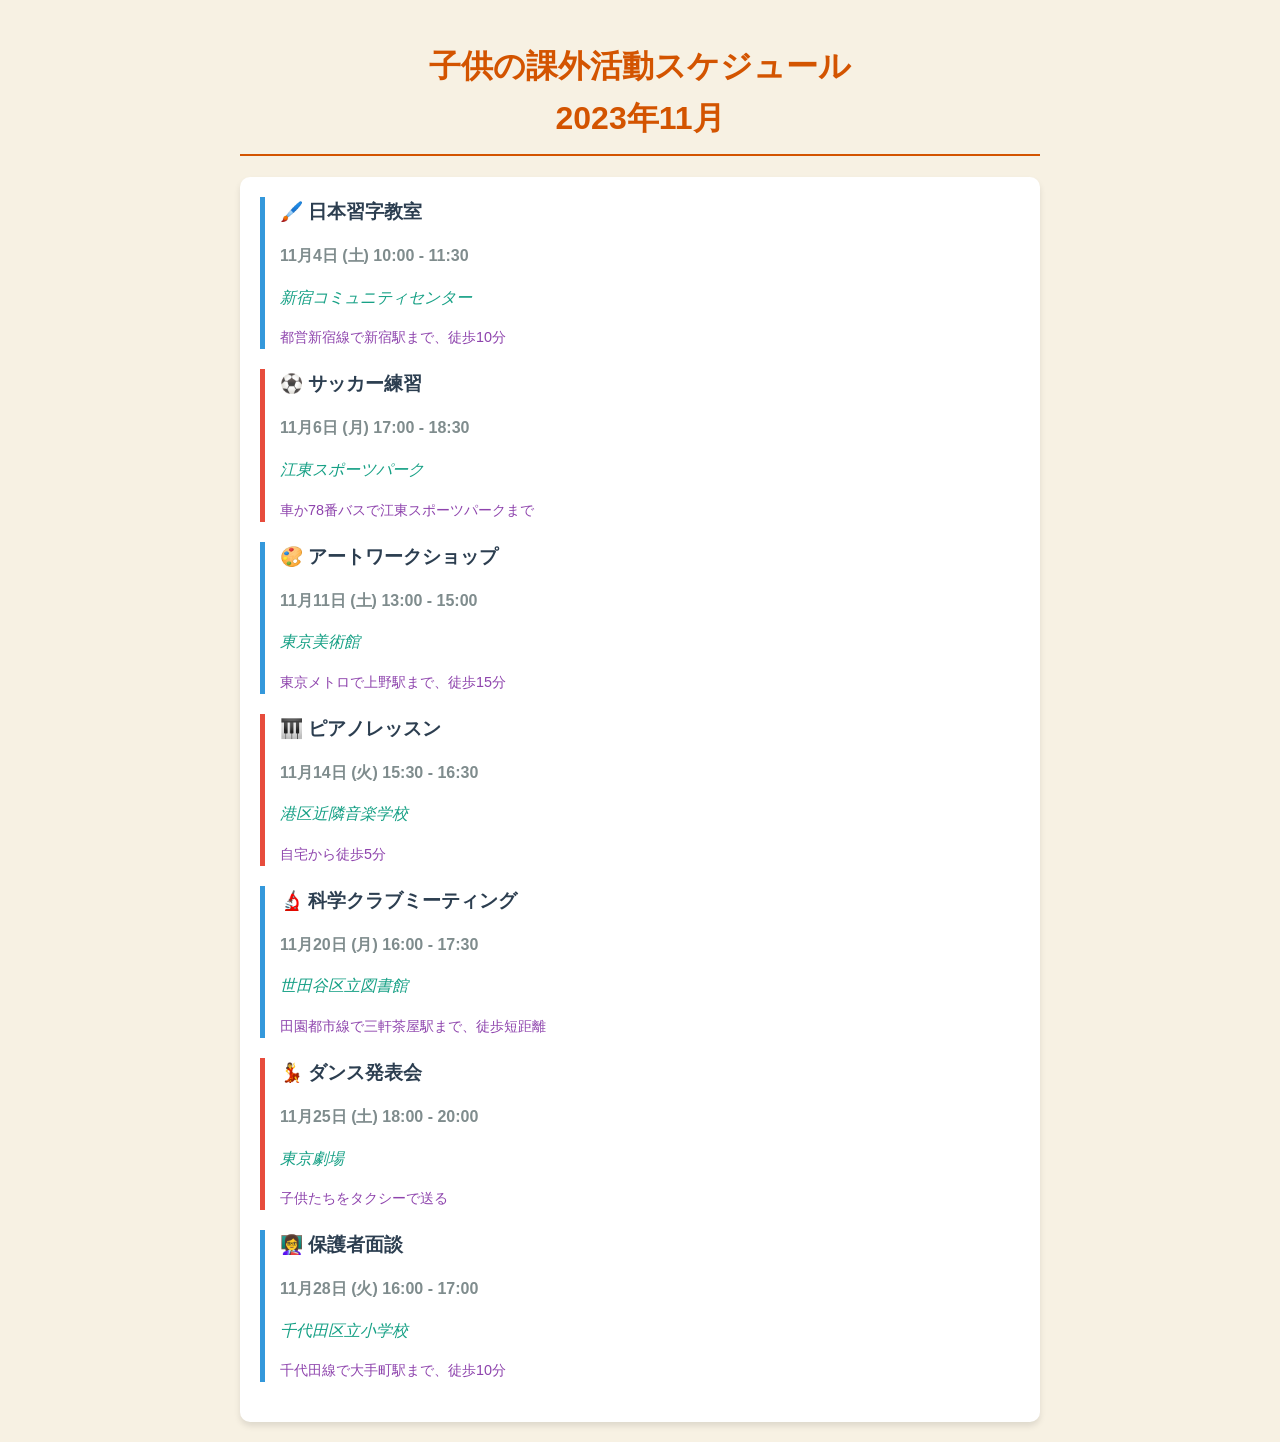What is the date of the Japanese Calligraphy class? The date for the Japanese Calligraphy class is specified in the schedule as November 4th.
Answer: 11月4日 What time does the Dance recital start? The schedule lists the start time of the Dance recital as 18:00 on November 25th.
Answer: 18:00 Where is the Science Club meeting held? The location for the Science Club meeting is noted in the document as 世田谷区立図書館.
Answer: 世田谷区立図書館 How long is the Piano lesson? The duration of the Piano lesson is given as one hour in the schedule.
Answer: 1時間 Which transportation method is suggested for the Art Workshop? The document indicates that the suggested transportation for the Art Workshop is via the Tokyo Metro.
Answer: 東京メトロ What is the end time for the Soccer practice? The end time for the Soccer practice is detailed in the schedule as 18:30 on November 6th.
Answer: 18:30 How do you get to the Parent-Teacher Meeting? The transportation method to the Parent-Teacher Meeting is listed as taking the Chiyoda Line and walking for 10 minutes.
Answer: 千代田線で大手町駅まで、徒歩10分 On what day is the Art Workshop scheduled? The Art Workshop is scheduled for a Saturday, which is indicated in the schedule as November 11th.
Answer: 11月11日 